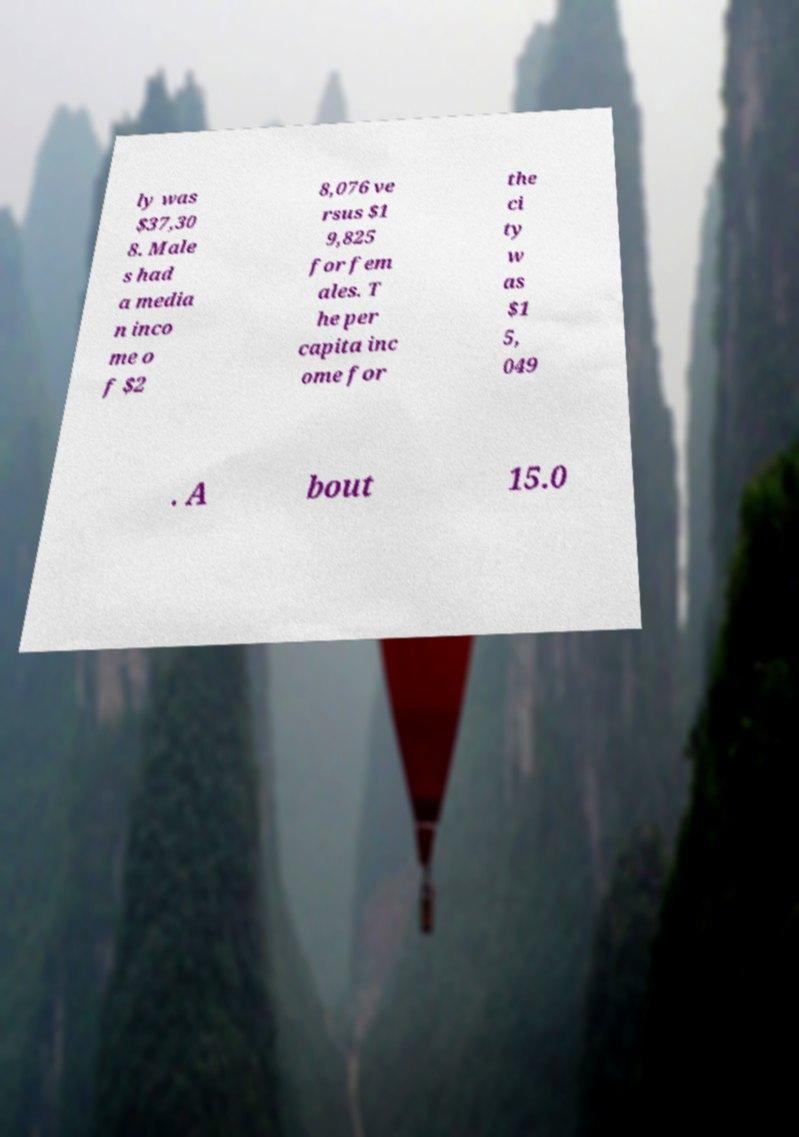Please read and relay the text visible in this image. What does it say? ly was $37,30 8. Male s had a media n inco me o f $2 8,076 ve rsus $1 9,825 for fem ales. T he per capita inc ome for the ci ty w as $1 5, 049 . A bout 15.0 